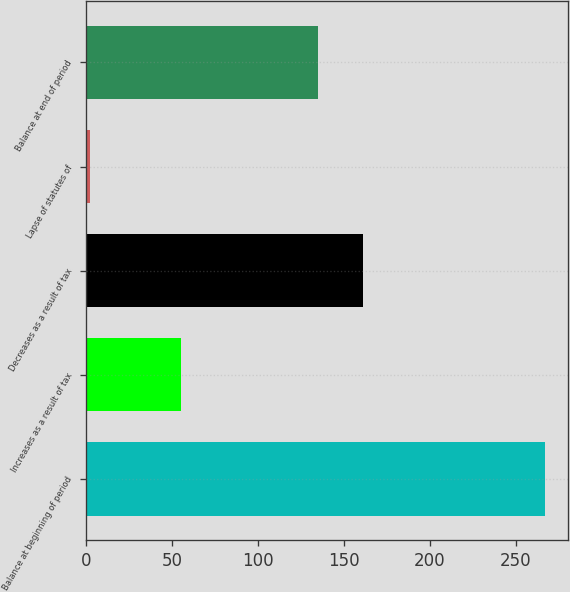Convert chart. <chart><loc_0><loc_0><loc_500><loc_500><bar_chart><fcel>Balance at beginning of period<fcel>Increases as a result of tax<fcel>Decreases as a result of tax<fcel>Lapse of statutes of<fcel>Balance at end of period<nl><fcel>266.9<fcel>55.3<fcel>161.25<fcel>2.4<fcel>134.8<nl></chart> 